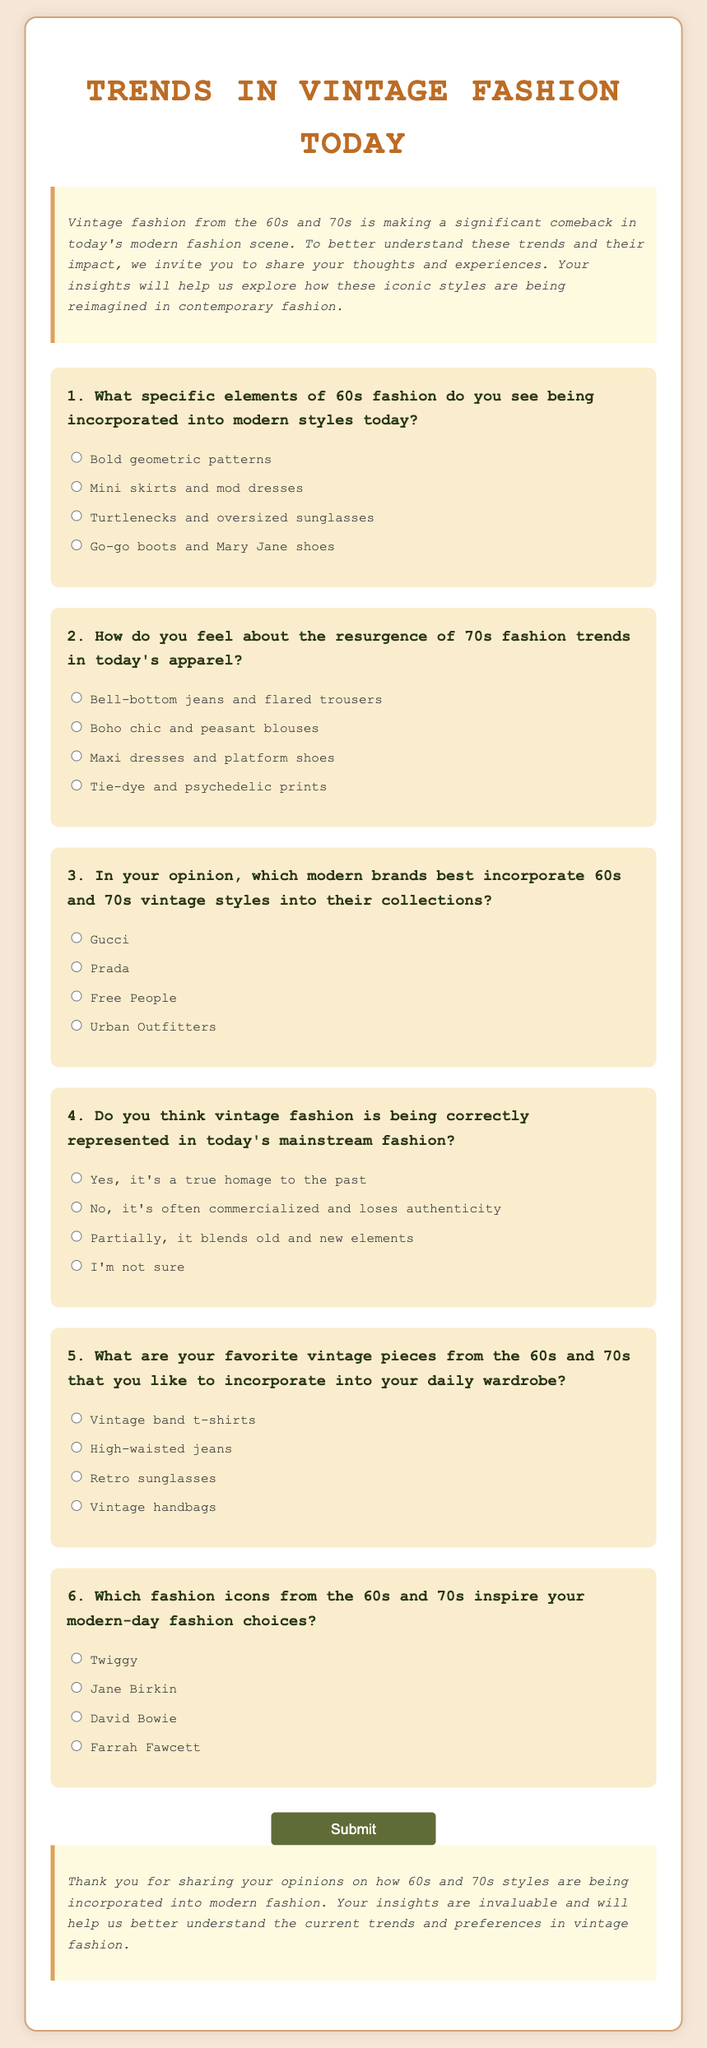What is the title of the questionnaire? The document begins with a large heading that states the title of the questionnaire.
Answer: Trends in Vintage Fashion Today Which decade's fashion is being discussed in the questions? The introduction mentions the focus on vintage fashion from the 60s and 70s.
Answer: 60s and 70s What is the first question asking about? The first question asks about specific elements of 60s fashion seen in modern styles.
Answer: Elements of 60s fashion How many options are provided for the second question? The second question lists four options regarding 70s fashion trends.
Answer: Four Which fashion icon from the 60s or 70s is mentioned as an option in the sixth question? The sixth question includes names of popular fashion icons from the stated decades.
Answer: Twiggy What option is given for the fourth question regarding the representation of vintage fashion? The questionnaire offers multiple responses related to the representation of vintage fashion in mainstream fashion.
Answer: True homage to the past How does the document conclude? The conclusion section summarizes the intention of the questionnaire and thanks participants for their insights.
Answer: Thank you for sharing your opinions 